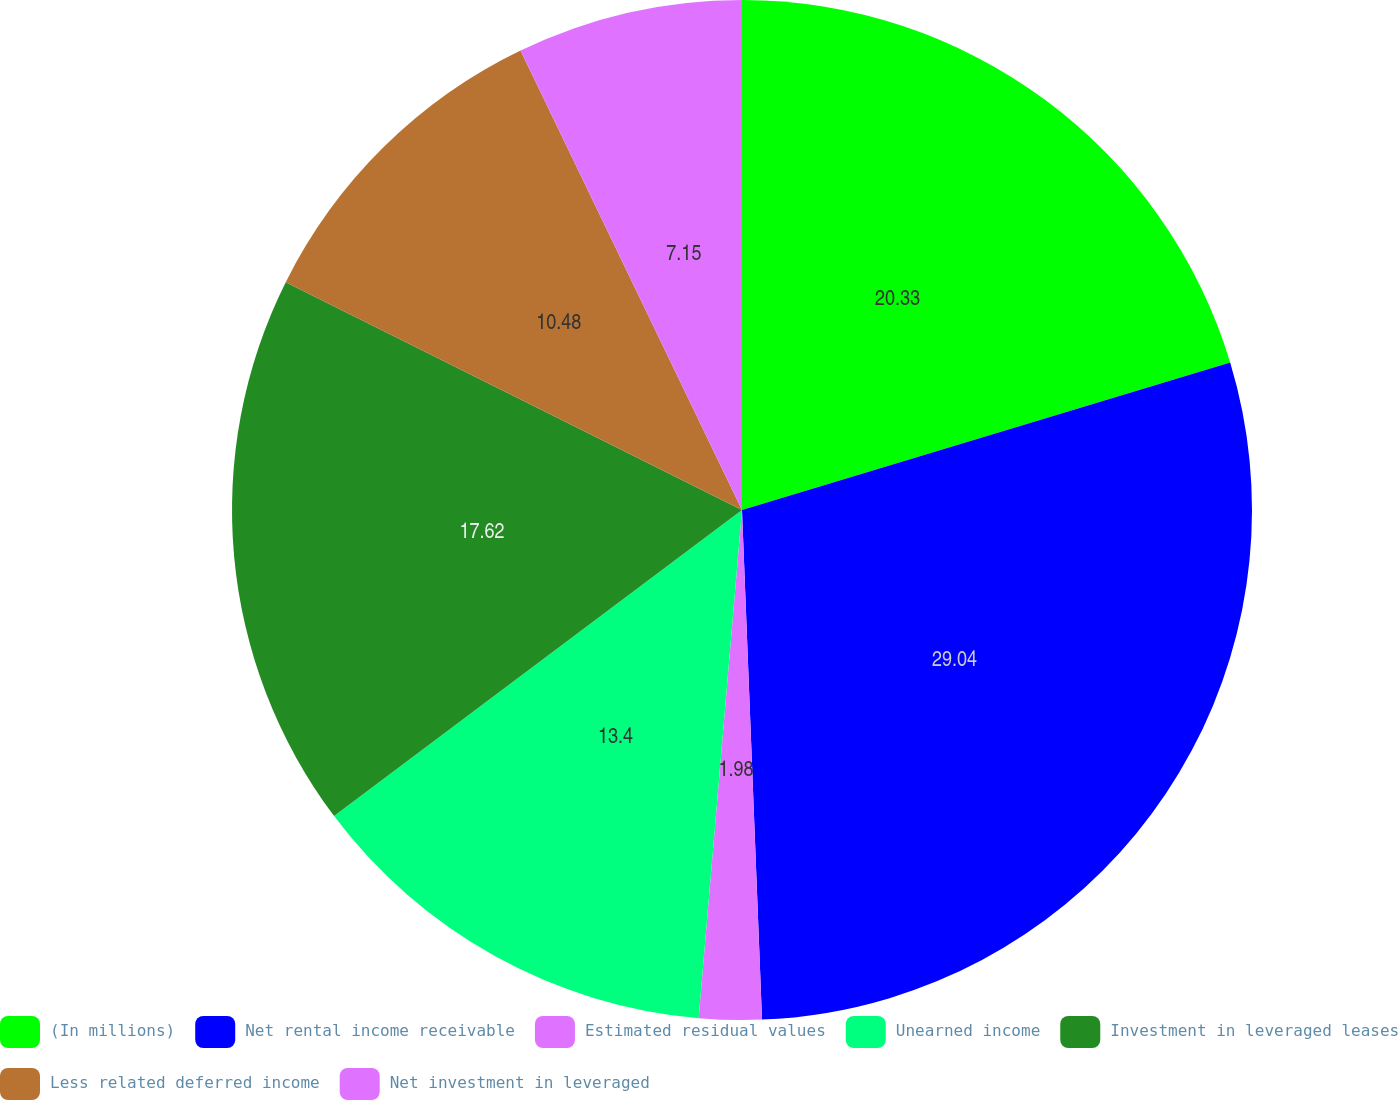Convert chart to OTSL. <chart><loc_0><loc_0><loc_500><loc_500><pie_chart><fcel>(In millions)<fcel>Net rental income receivable<fcel>Estimated residual values<fcel>Unearned income<fcel>Investment in leveraged leases<fcel>Less related deferred income<fcel>Net investment in leveraged<nl><fcel>20.33%<fcel>29.05%<fcel>1.98%<fcel>13.4%<fcel>17.62%<fcel>10.48%<fcel>7.15%<nl></chart> 